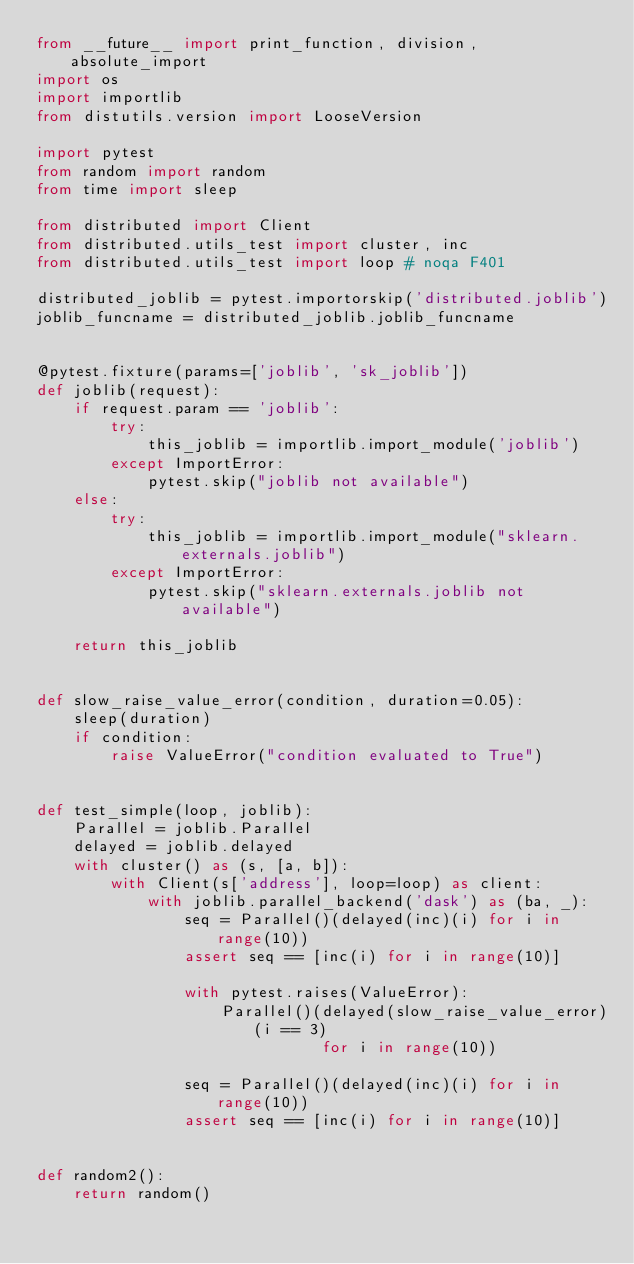<code> <loc_0><loc_0><loc_500><loc_500><_Python_>from __future__ import print_function, division, absolute_import
import os
import importlib
from distutils.version import LooseVersion

import pytest
from random import random
from time import sleep

from distributed import Client
from distributed.utils_test import cluster, inc
from distributed.utils_test import loop # noqa F401

distributed_joblib = pytest.importorskip('distributed.joblib')
joblib_funcname = distributed_joblib.joblib_funcname


@pytest.fixture(params=['joblib', 'sk_joblib'])
def joblib(request):
    if request.param == 'joblib':
        try:
            this_joblib = importlib.import_module('joblib')
        except ImportError:
            pytest.skip("joblib not available")
    else:
        try:
            this_joblib = importlib.import_module("sklearn.externals.joblib")
        except ImportError:
            pytest.skip("sklearn.externals.joblib not available")

    return this_joblib


def slow_raise_value_error(condition, duration=0.05):
    sleep(duration)
    if condition:
        raise ValueError("condition evaluated to True")


def test_simple(loop, joblib):
    Parallel = joblib.Parallel
    delayed = joblib.delayed
    with cluster() as (s, [a, b]):
        with Client(s['address'], loop=loop) as client:
            with joblib.parallel_backend('dask') as (ba, _):
                seq = Parallel()(delayed(inc)(i) for i in range(10))
                assert seq == [inc(i) for i in range(10)]

                with pytest.raises(ValueError):
                    Parallel()(delayed(slow_raise_value_error)(i == 3)
                               for i in range(10))

                seq = Parallel()(delayed(inc)(i) for i in range(10))
                assert seq == [inc(i) for i in range(10)]


def random2():
    return random()

</code> 